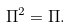Convert formula to latex. <formula><loc_0><loc_0><loc_500><loc_500>\Pi ^ { 2 } = \Pi .</formula> 